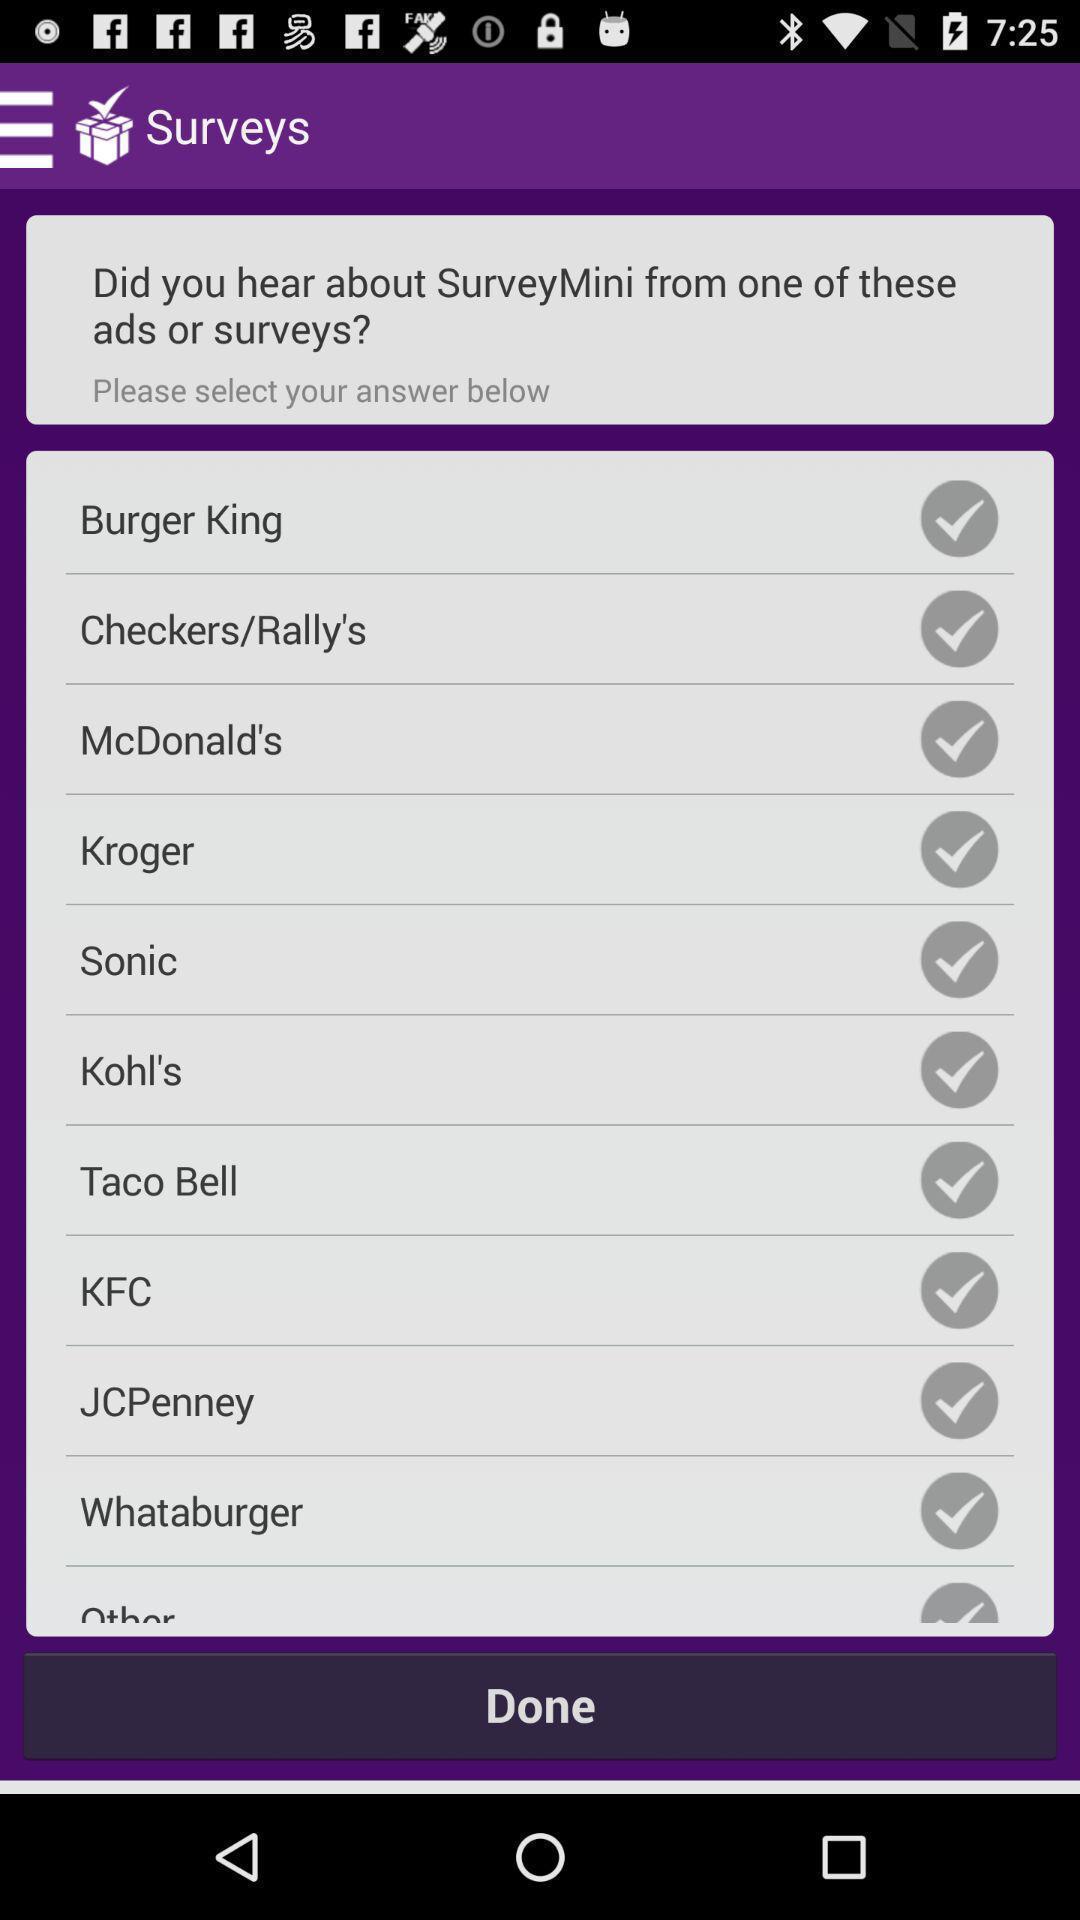What is the overall content of this screenshot? Various restaurants page displayed of a fun app. 